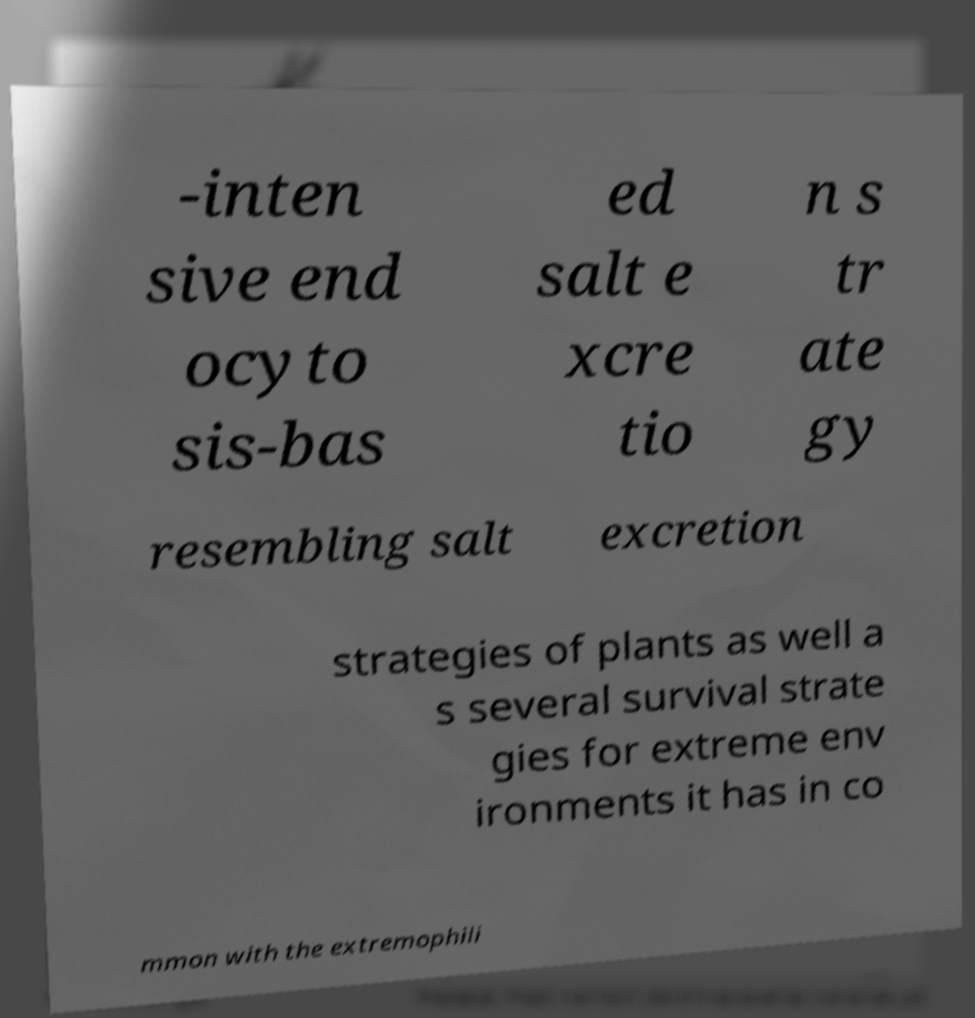Can you accurately transcribe the text from the provided image for me? -inten sive end ocyto sis-bas ed salt e xcre tio n s tr ate gy resembling salt excretion strategies of plants as well a s several survival strate gies for extreme env ironments it has in co mmon with the extremophili 